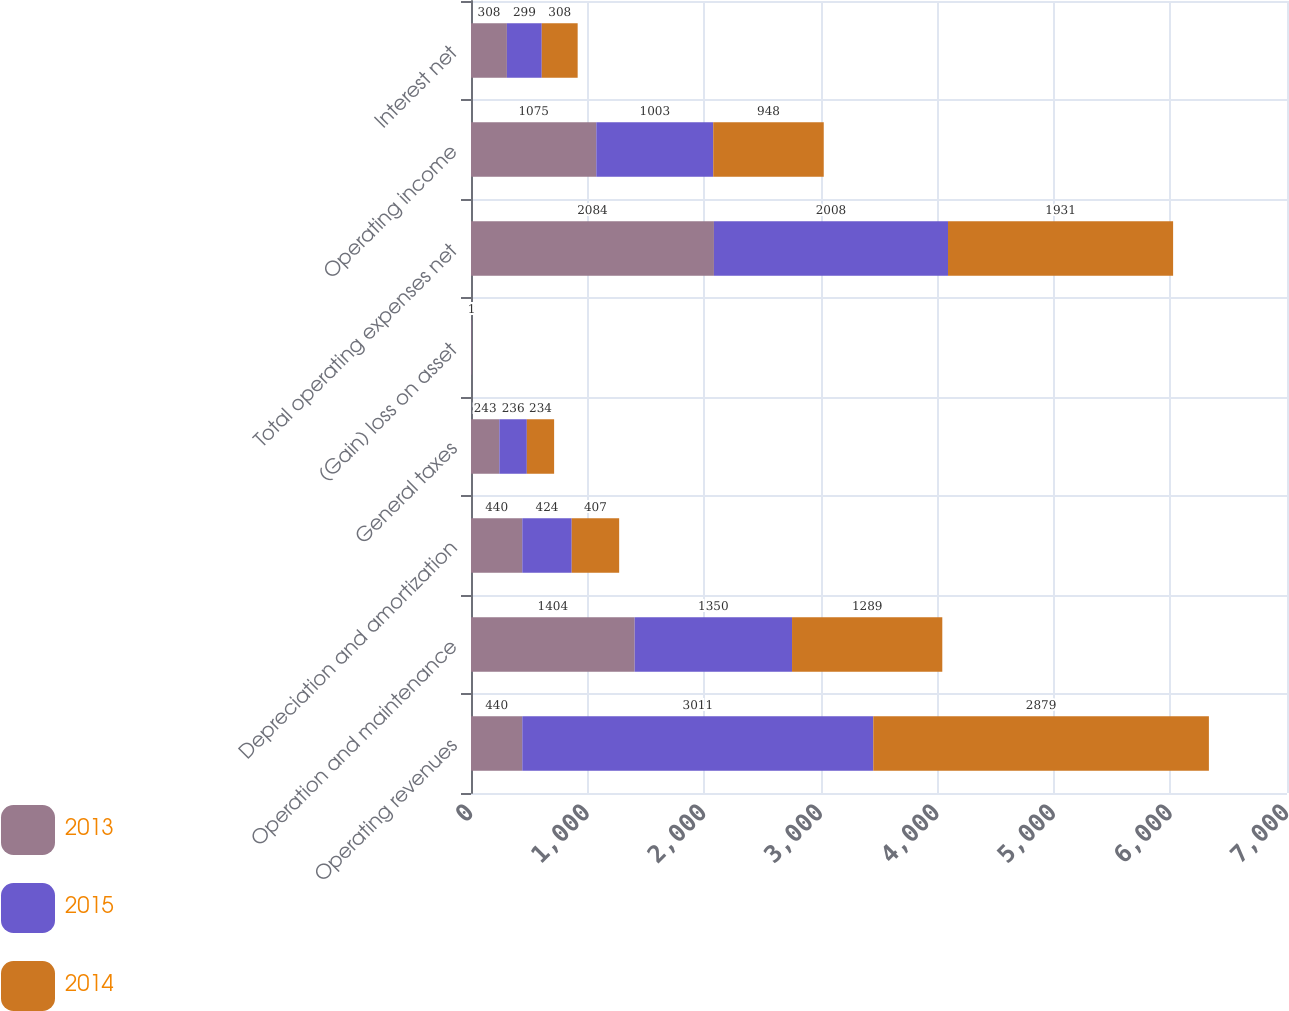Convert chart to OTSL. <chart><loc_0><loc_0><loc_500><loc_500><stacked_bar_chart><ecel><fcel>Operating revenues<fcel>Operation and maintenance<fcel>Depreciation and amortization<fcel>General taxes<fcel>(Gain) loss on asset<fcel>Total operating expenses net<fcel>Operating income<fcel>Interest net<nl><fcel>2013<fcel>440<fcel>1404<fcel>440<fcel>243<fcel>3<fcel>2084<fcel>1075<fcel>308<nl><fcel>2015<fcel>3011<fcel>1350<fcel>424<fcel>236<fcel>2<fcel>2008<fcel>1003<fcel>299<nl><fcel>2014<fcel>2879<fcel>1289<fcel>407<fcel>234<fcel>1<fcel>1931<fcel>948<fcel>308<nl></chart> 